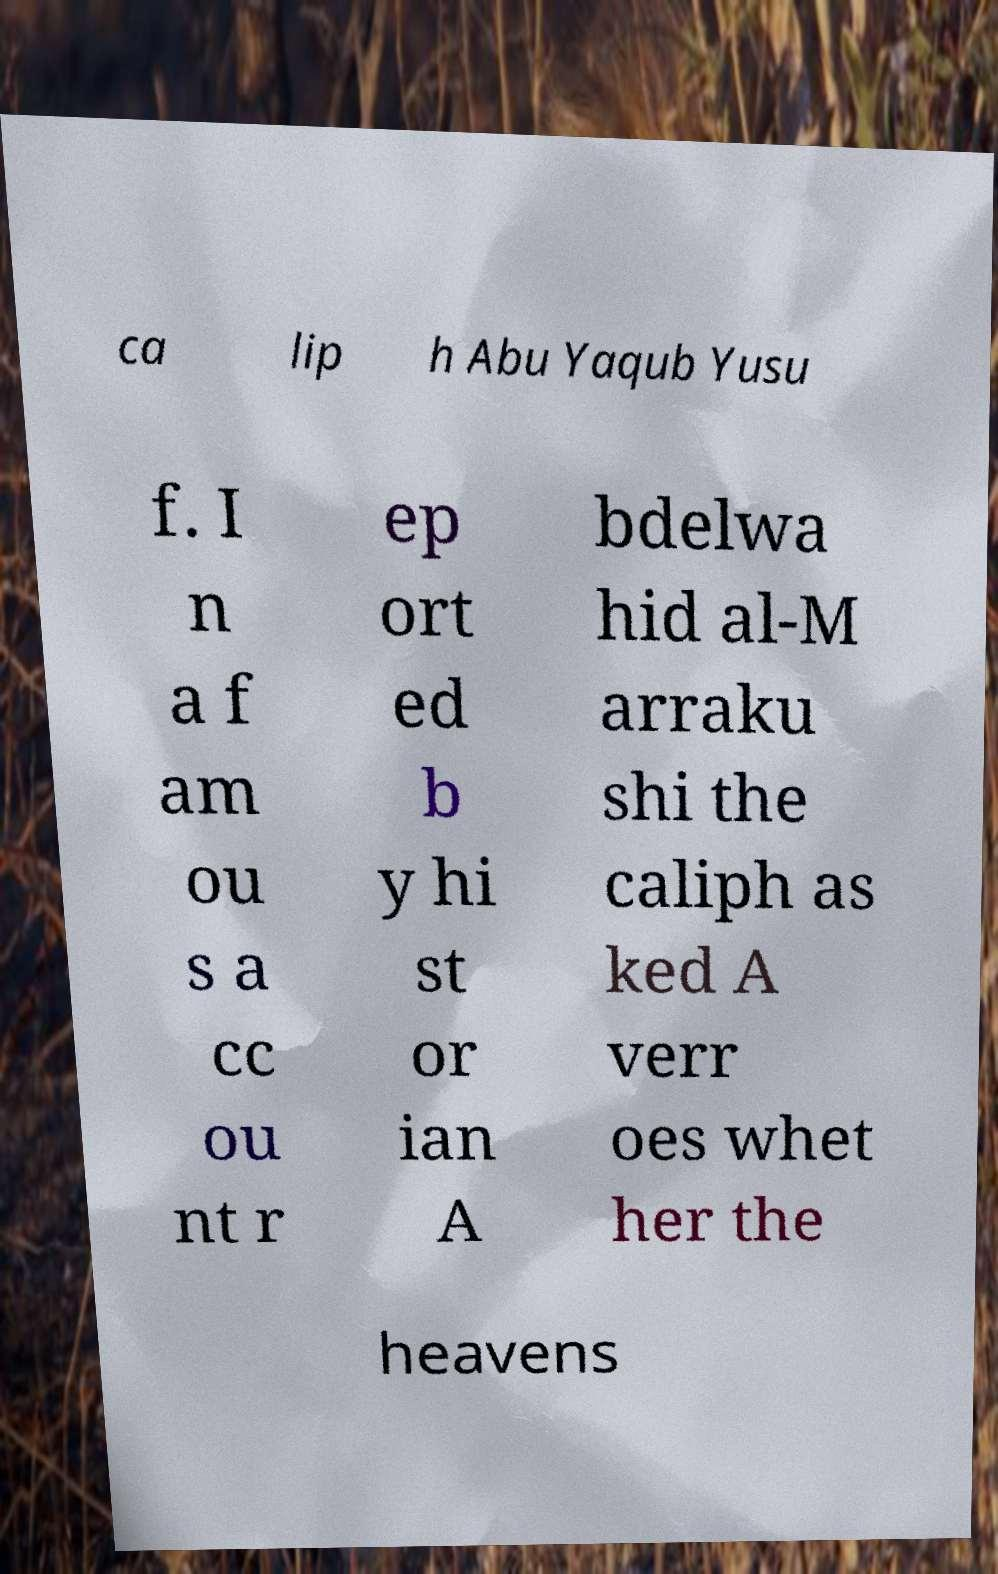Please read and relay the text visible in this image. What does it say? ca lip h Abu Yaqub Yusu f. I n a f am ou s a cc ou nt r ep ort ed b y hi st or ian A bdelwa hid al-M arraku shi the caliph as ked A verr oes whet her the heavens 